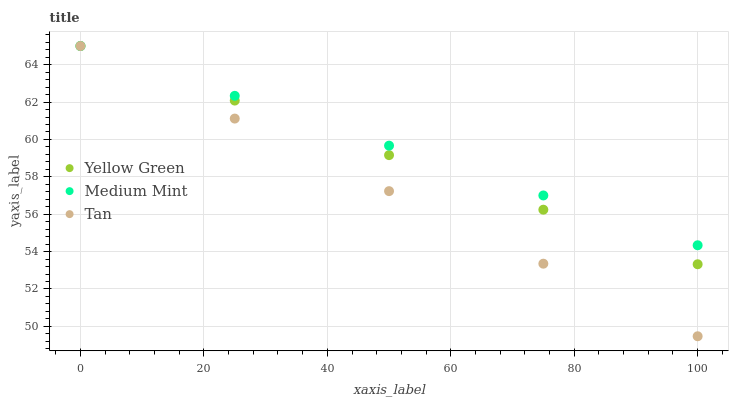Does Tan have the minimum area under the curve?
Answer yes or no. Yes. Does Medium Mint have the maximum area under the curve?
Answer yes or no. Yes. Does Yellow Green have the minimum area under the curve?
Answer yes or no. No. Does Yellow Green have the maximum area under the curve?
Answer yes or no. No. Is Medium Mint the smoothest?
Answer yes or no. Yes. Is Yellow Green the roughest?
Answer yes or no. Yes. Is Tan the smoothest?
Answer yes or no. No. Is Tan the roughest?
Answer yes or no. No. Does Tan have the lowest value?
Answer yes or no. Yes. Does Yellow Green have the lowest value?
Answer yes or no. No. Does Yellow Green have the highest value?
Answer yes or no. Yes. Does Medium Mint intersect Yellow Green?
Answer yes or no. Yes. Is Medium Mint less than Yellow Green?
Answer yes or no. No. Is Medium Mint greater than Yellow Green?
Answer yes or no. No. 